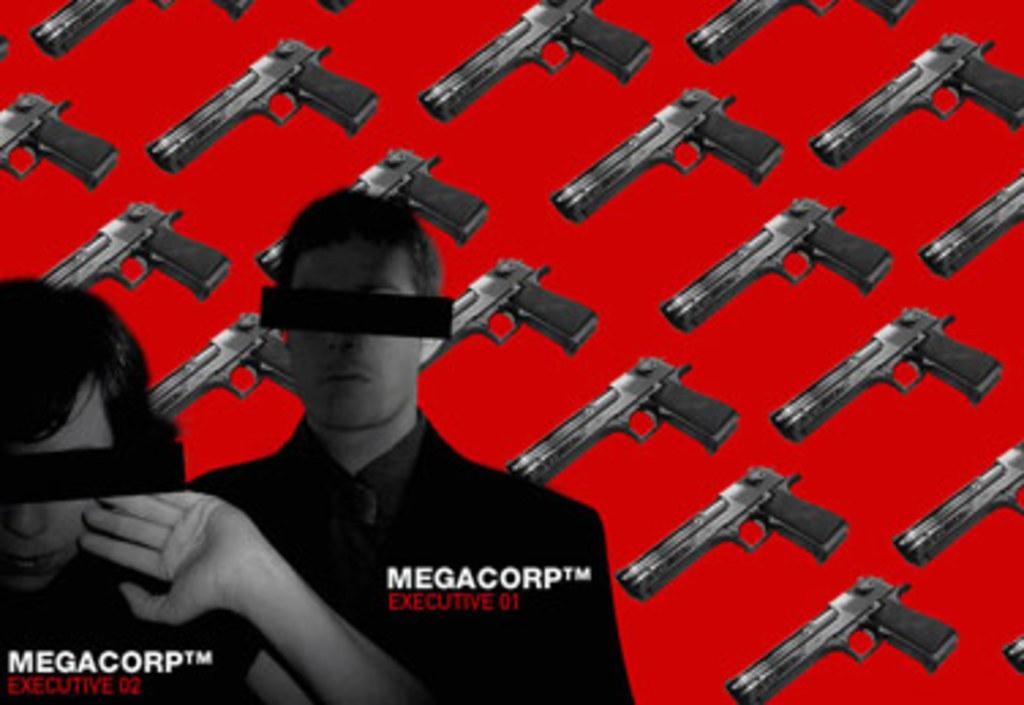Who can be seen on the left side of the image? There is a man and a woman on the left side of the image. What is the relationship between the man and the woman in the image? The relationship between the man and the woman is not specified in the image. What can be seen in the background of the image? There are many guns in the background of the image. What type of wing can be seen on the man in the image? There is no wing visible on the man in the image. 